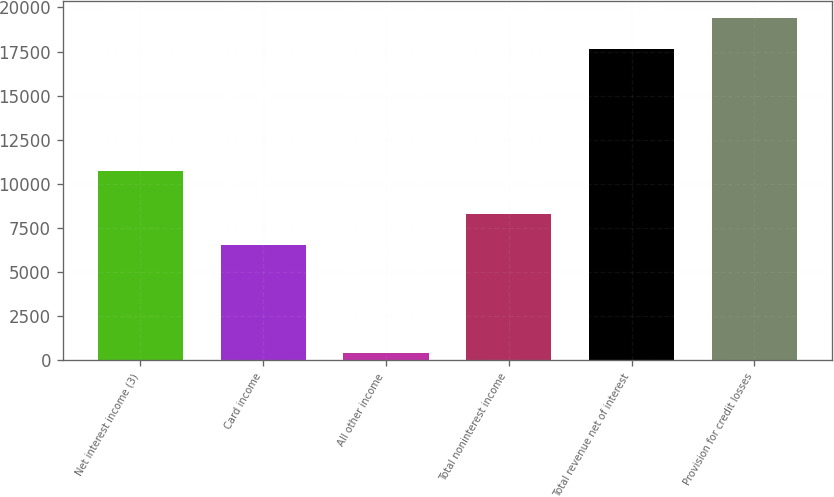Convert chart. <chart><loc_0><loc_0><loc_500><loc_500><bar_chart><fcel>Net interest income (3)<fcel>Card income<fcel>All other income<fcel>Total noninterest income<fcel>Total revenue net of interest<fcel>Provision for credit losses<nl><fcel>10722<fcel>6519<fcel>406<fcel>8293.8<fcel>17647<fcel>19421.8<nl></chart> 